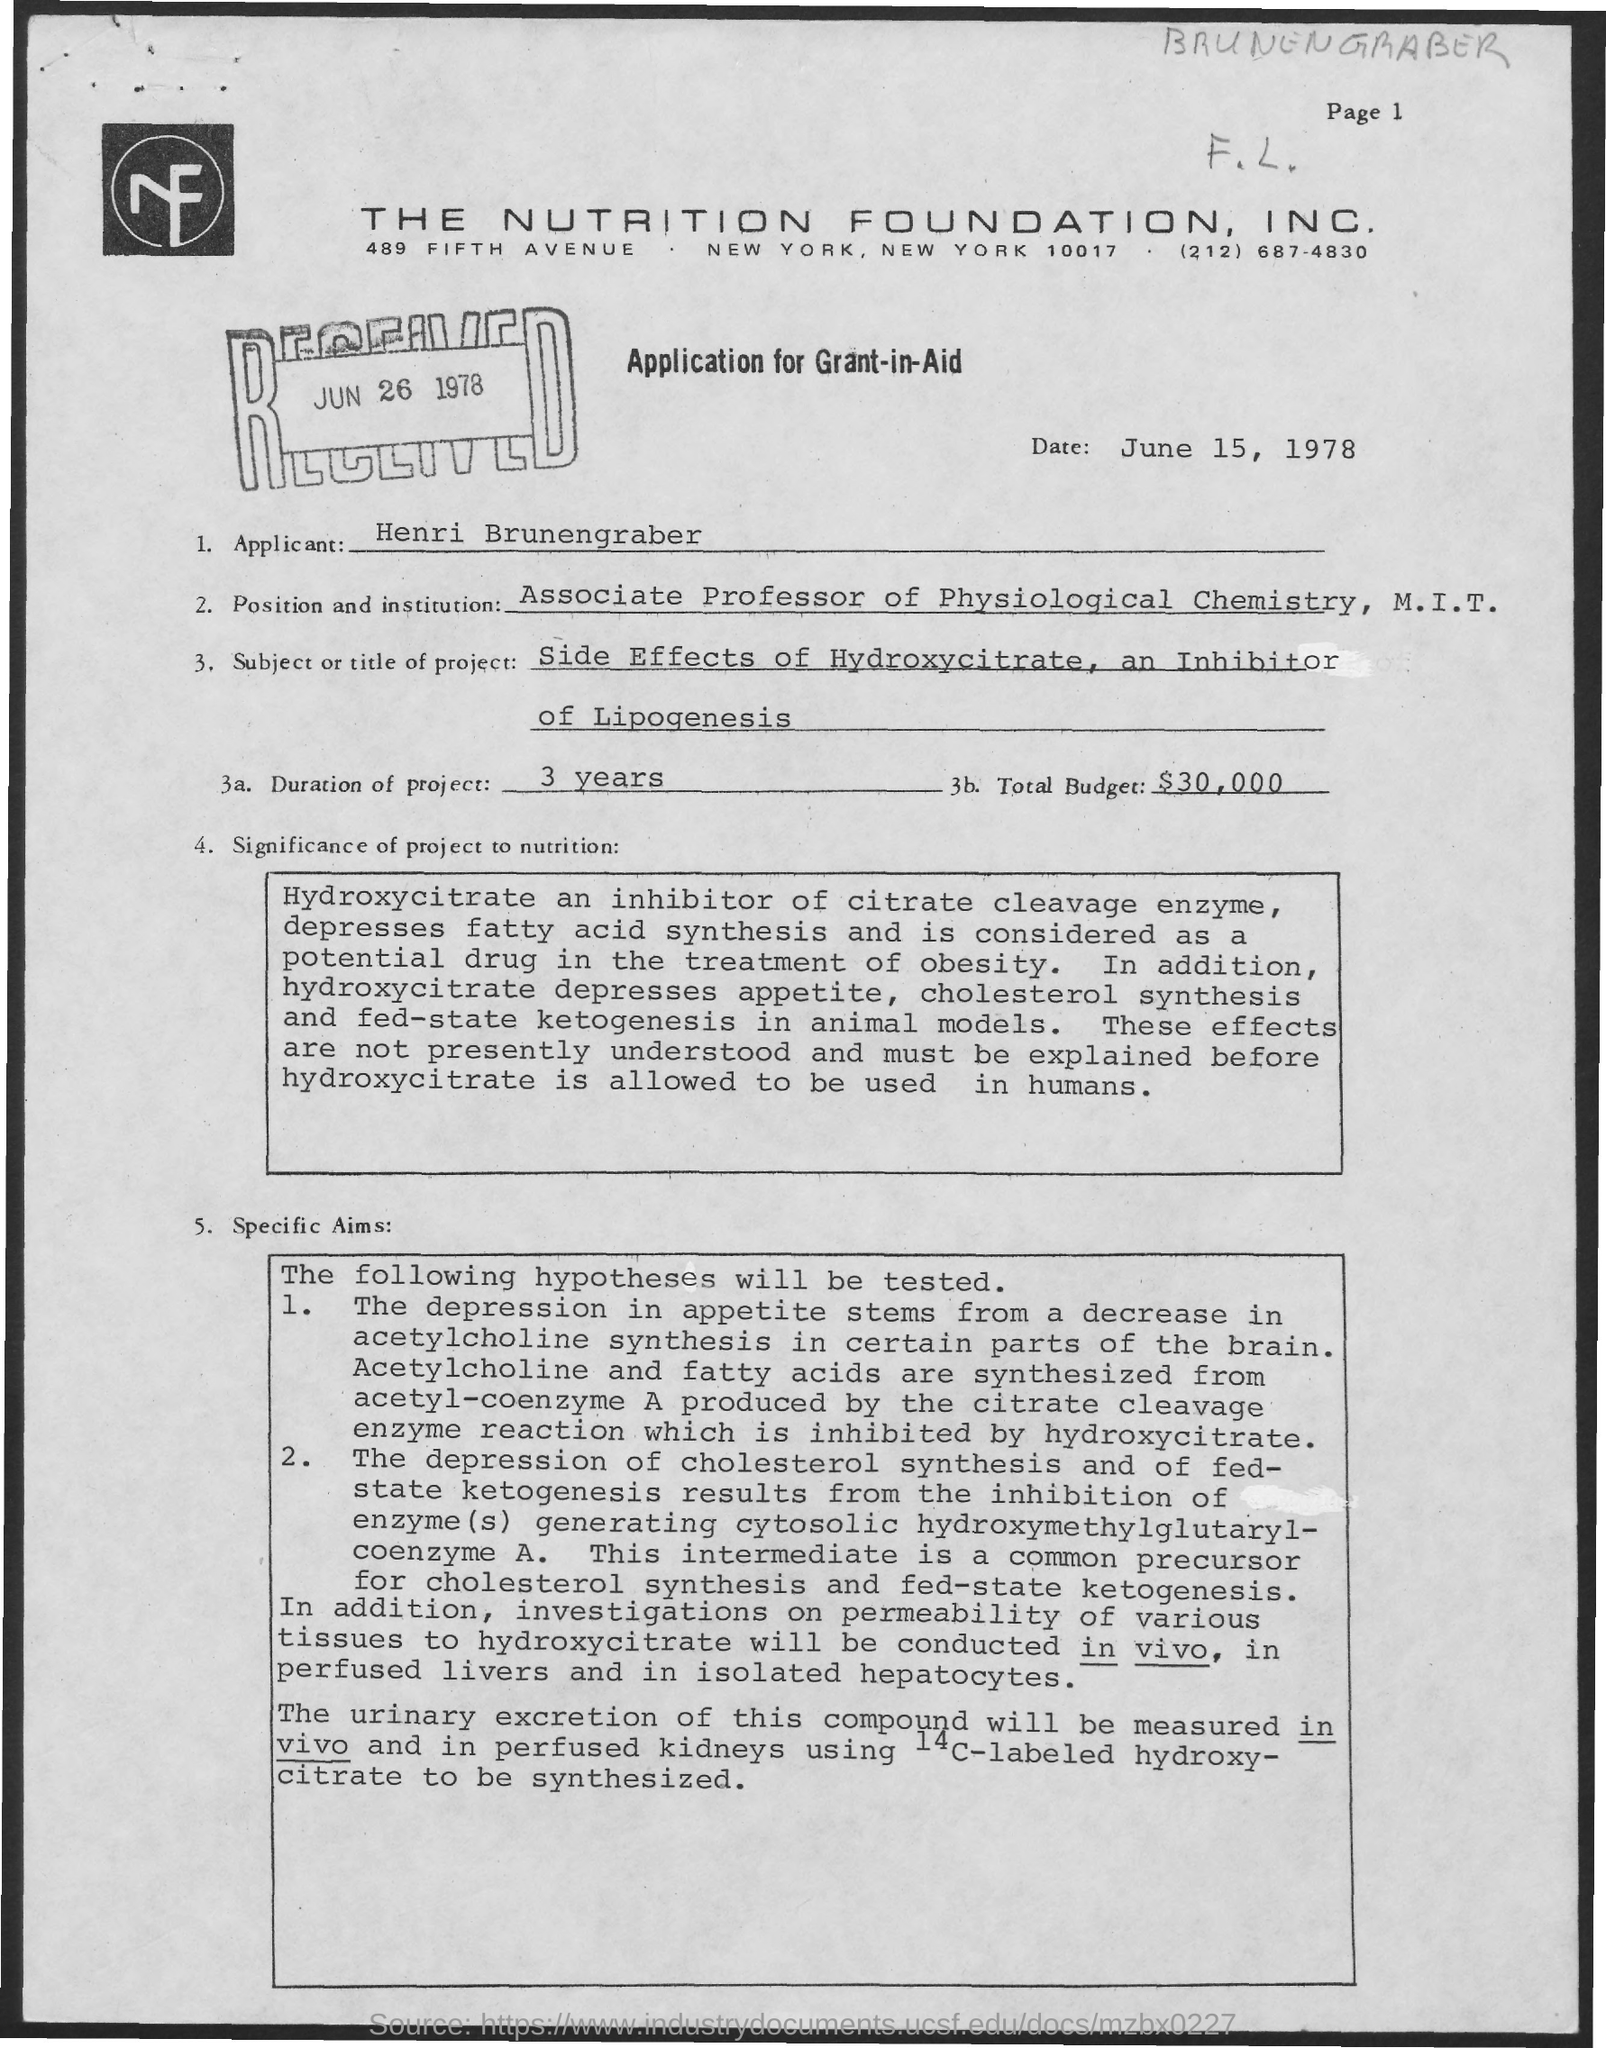What is the name of the applicant mentioned in the given letter ?
Keep it short and to the point. Henri Brunengraber. What is the position and institution mentioned in the given letter ?
Make the answer very short. Associate Professor of Physiological Chemistry , M.I.T. What is the date mentioned in the given page ?
Provide a short and direct response. June 15 , 1978. On which date the letter was received ?
Your response must be concise. JUN 26 1978. What is the subject or title of the project mentioned in the given letter ?
Your answer should be compact. Side effects of hydroxycitrate, an inhibitor of lipogenesis. What is the duration of the project mentioned in the given letter ?
Provide a short and direct response. 3. What is the total budget mentioned in the given letter ?
Your response must be concise. $30,000. 